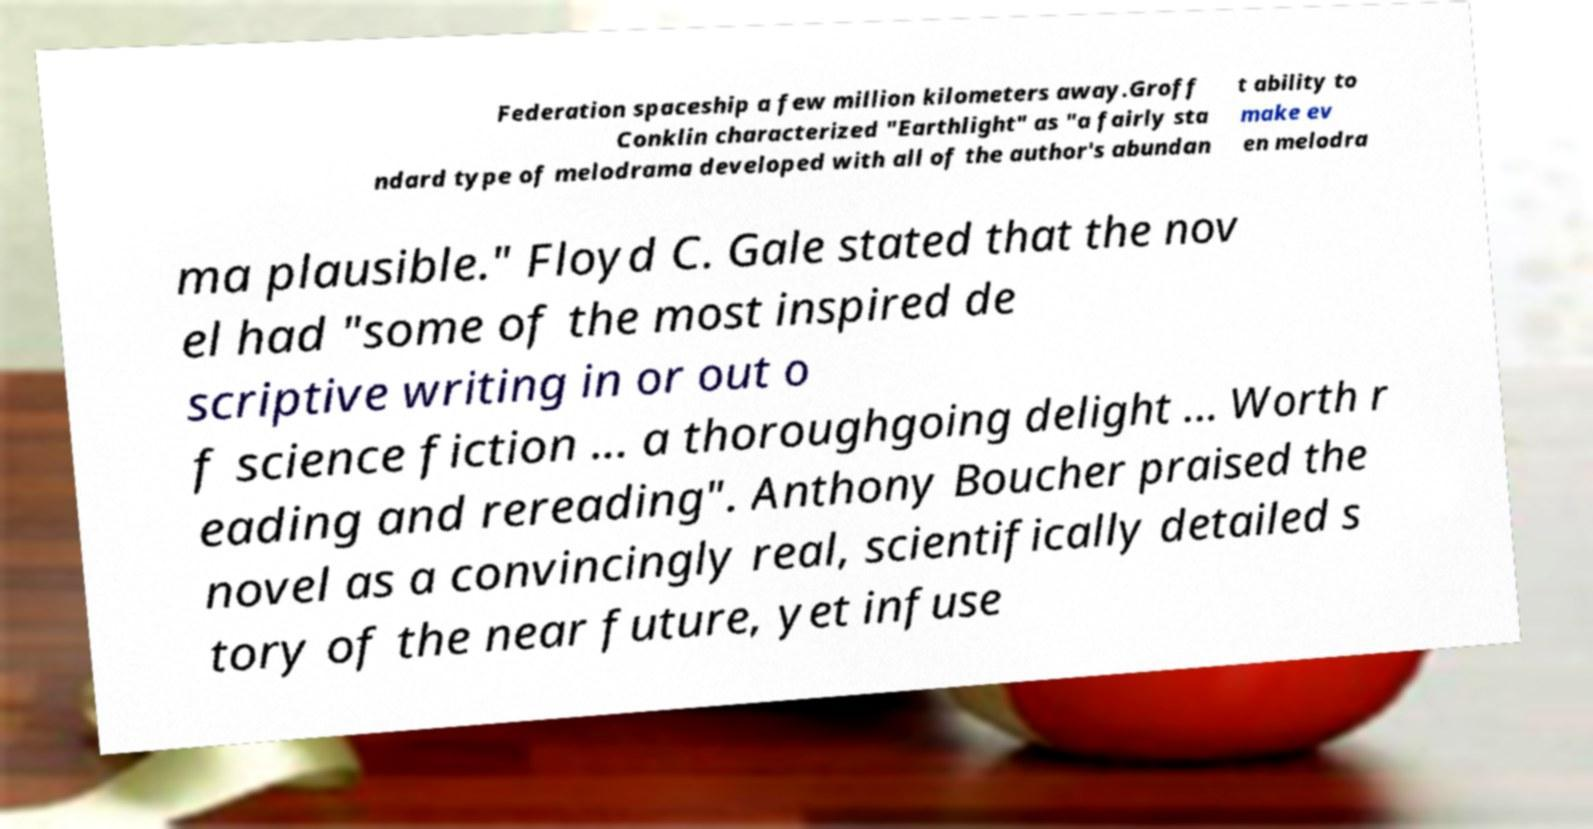Please read and relay the text visible in this image. What does it say? Federation spaceship a few million kilometers away.Groff Conklin characterized "Earthlight" as "a fairly sta ndard type of melodrama developed with all of the author's abundan t ability to make ev en melodra ma plausible." Floyd C. Gale stated that the nov el had "some of the most inspired de scriptive writing in or out o f science fiction ... a thoroughgoing delight ... Worth r eading and rereading". Anthony Boucher praised the novel as a convincingly real, scientifically detailed s tory of the near future, yet infuse 